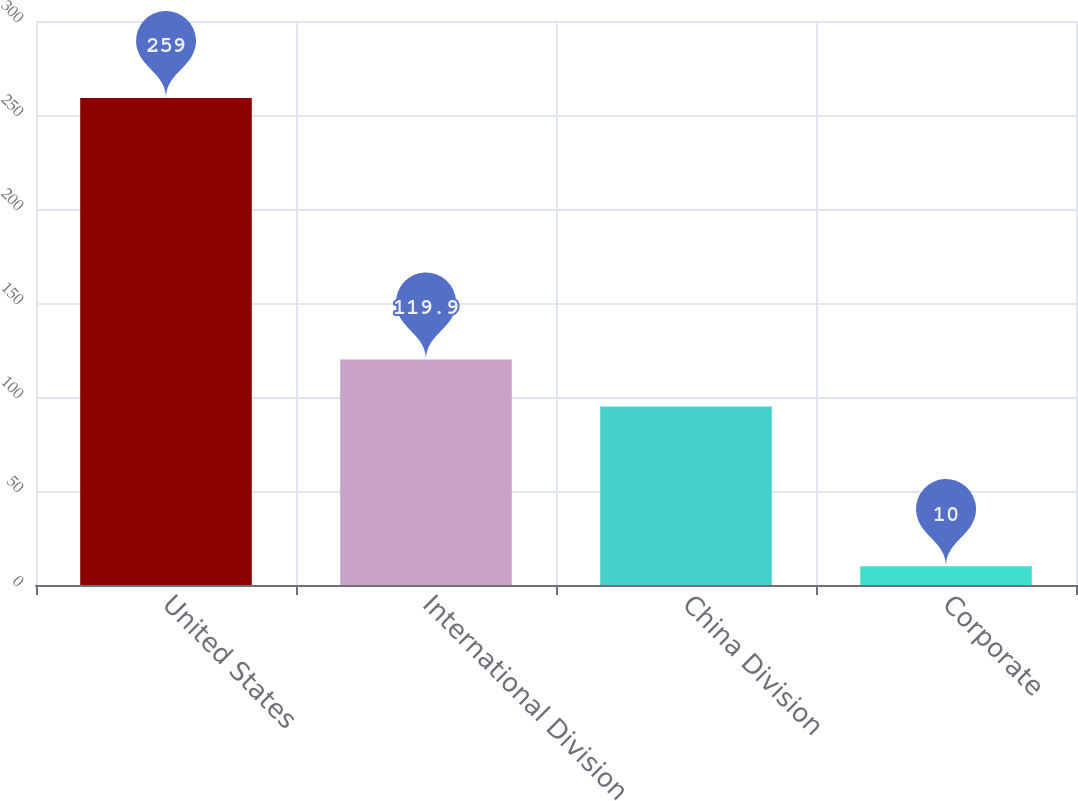Convert chart. <chart><loc_0><loc_0><loc_500><loc_500><bar_chart><fcel>United States<fcel>International Division<fcel>China Division<fcel>Corporate<nl><fcel>259<fcel>119.9<fcel>95<fcel>10<nl></chart> 